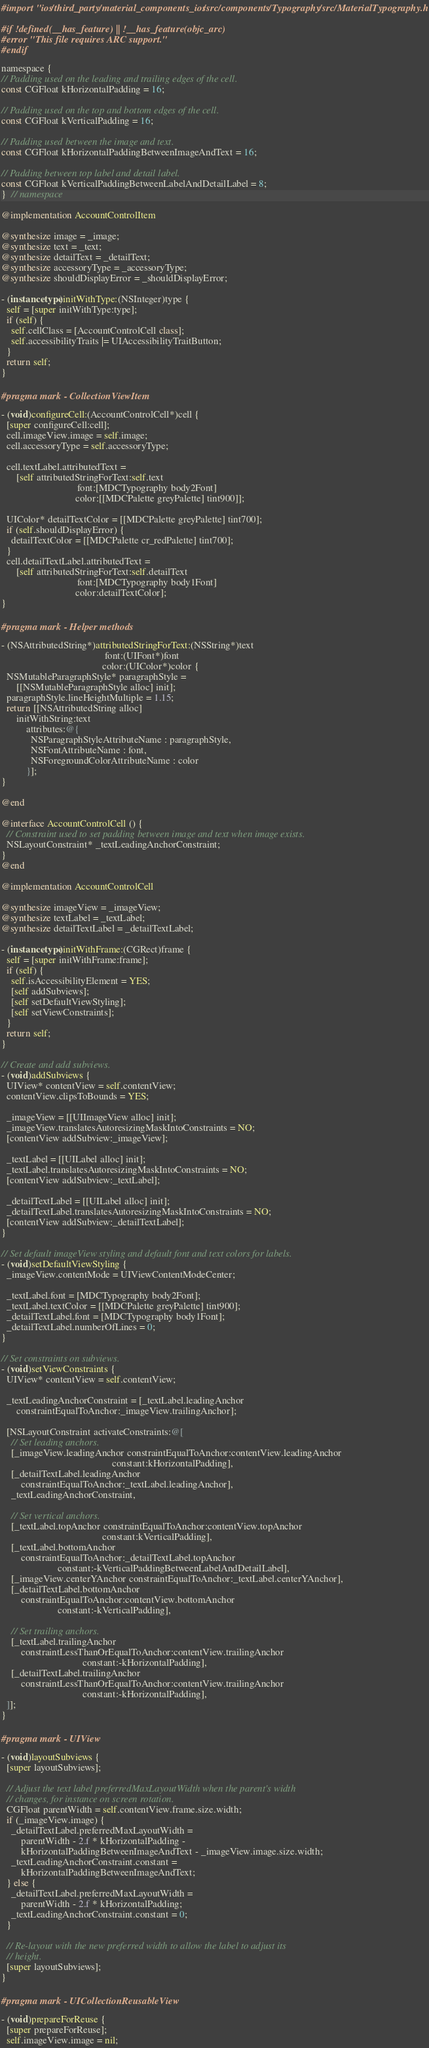<code> <loc_0><loc_0><loc_500><loc_500><_ObjectiveC_>#import "ios/third_party/material_components_ios/src/components/Typography/src/MaterialTypography.h"

#if !defined(__has_feature) || !__has_feature(objc_arc)
#error "This file requires ARC support."
#endif

namespace {
// Padding used on the leading and trailing edges of the cell.
const CGFloat kHorizontalPadding = 16;

// Padding used on the top and bottom edges of the cell.
const CGFloat kVerticalPadding = 16;

// Padding used between the image and text.
const CGFloat kHorizontalPaddingBetweenImageAndText = 16;

// Padding between top label and detail label.
const CGFloat kVerticalPaddingBetweenLabelAndDetailLabel = 8;
}  // namespace

@implementation AccountControlItem

@synthesize image = _image;
@synthesize text = _text;
@synthesize detailText = _detailText;
@synthesize accessoryType = _accessoryType;
@synthesize shouldDisplayError = _shouldDisplayError;

- (instancetype)initWithType:(NSInteger)type {
  self = [super initWithType:type];
  if (self) {
    self.cellClass = [AccountControlCell class];
    self.accessibilityTraits |= UIAccessibilityTraitButton;
  }
  return self;
}

#pragma mark - CollectionViewItem

- (void)configureCell:(AccountControlCell*)cell {
  [super configureCell:cell];
  cell.imageView.image = self.image;
  cell.accessoryType = self.accessoryType;

  cell.textLabel.attributedText =
      [self attributedStringForText:self.text
                               font:[MDCTypography body2Font]
                              color:[[MDCPalette greyPalette] tint900]];

  UIColor* detailTextColor = [[MDCPalette greyPalette] tint700];
  if (self.shouldDisplayError) {
    detailTextColor = [[MDCPalette cr_redPalette] tint700];
  }
  cell.detailTextLabel.attributedText =
      [self attributedStringForText:self.detailText
                               font:[MDCTypography body1Font]
                              color:detailTextColor];
}

#pragma mark - Helper methods

- (NSAttributedString*)attributedStringForText:(NSString*)text
                                          font:(UIFont*)font
                                         color:(UIColor*)color {
  NSMutableParagraphStyle* paragraphStyle =
      [[NSMutableParagraphStyle alloc] init];
  paragraphStyle.lineHeightMultiple = 1.15;
  return [[NSAttributedString alloc]
      initWithString:text
          attributes:@{
            NSParagraphStyleAttributeName : paragraphStyle,
            NSFontAttributeName : font,
            NSForegroundColorAttributeName : color
          }];
}

@end

@interface AccountControlCell () {
  // Constraint used to set padding between image and text when image exists.
  NSLayoutConstraint* _textLeadingAnchorConstraint;
}
@end

@implementation AccountControlCell

@synthesize imageView = _imageView;
@synthesize textLabel = _textLabel;
@synthesize detailTextLabel = _detailTextLabel;

- (instancetype)initWithFrame:(CGRect)frame {
  self = [super initWithFrame:frame];
  if (self) {
    self.isAccessibilityElement = YES;
    [self addSubviews];
    [self setDefaultViewStyling];
    [self setViewConstraints];
  }
  return self;
}

// Create and add subviews.
- (void)addSubviews {
  UIView* contentView = self.contentView;
  contentView.clipsToBounds = YES;

  _imageView = [[UIImageView alloc] init];
  _imageView.translatesAutoresizingMaskIntoConstraints = NO;
  [contentView addSubview:_imageView];

  _textLabel = [[UILabel alloc] init];
  _textLabel.translatesAutoresizingMaskIntoConstraints = NO;
  [contentView addSubview:_textLabel];

  _detailTextLabel = [[UILabel alloc] init];
  _detailTextLabel.translatesAutoresizingMaskIntoConstraints = NO;
  [contentView addSubview:_detailTextLabel];
}

// Set default imageView styling and default font and text colors for labels.
- (void)setDefaultViewStyling {
  _imageView.contentMode = UIViewContentModeCenter;

  _textLabel.font = [MDCTypography body2Font];
  _textLabel.textColor = [[MDCPalette greyPalette] tint900];
  _detailTextLabel.font = [MDCTypography body1Font];
  _detailTextLabel.numberOfLines = 0;
}

// Set constraints on subviews.
- (void)setViewConstraints {
  UIView* contentView = self.contentView;

  _textLeadingAnchorConstraint = [_textLabel.leadingAnchor
      constraintEqualToAnchor:_imageView.trailingAnchor];

  [NSLayoutConstraint activateConstraints:@[
    // Set leading anchors.
    [_imageView.leadingAnchor constraintEqualToAnchor:contentView.leadingAnchor
                                             constant:kHorizontalPadding],
    [_detailTextLabel.leadingAnchor
        constraintEqualToAnchor:_textLabel.leadingAnchor],
    _textLeadingAnchorConstraint,

    // Set vertical anchors.
    [_textLabel.topAnchor constraintEqualToAnchor:contentView.topAnchor
                                         constant:kVerticalPadding],
    [_textLabel.bottomAnchor
        constraintEqualToAnchor:_detailTextLabel.topAnchor
                       constant:-kVerticalPaddingBetweenLabelAndDetailLabel],
    [_imageView.centerYAnchor constraintEqualToAnchor:_textLabel.centerYAnchor],
    [_detailTextLabel.bottomAnchor
        constraintEqualToAnchor:contentView.bottomAnchor
                       constant:-kVerticalPadding],

    // Set trailing anchors.
    [_textLabel.trailingAnchor
        constraintLessThanOrEqualToAnchor:contentView.trailingAnchor
                                 constant:-kHorizontalPadding],
    [_detailTextLabel.trailingAnchor
        constraintLessThanOrEqualToAnchor:contentView.trailingAnchor
                                 constant:-kHorizontalPadding],
  ]];
}

#pragma mark - UIView

- (void)layoutSubviews {
  [super layoutSubviews];

  // Adjust the text label preferredMaxLayoutWidth when the parent's width
  // changes, for instance on screen rotation.
  CGFloat parentWidth = self.contentView.frame.size.width;
  if (_imageView.image) {
    _detailTextLabel.preferredMaxLayoutWidth =
        parentWidth - 2.f * kHorizontalPadding -
        kHorizontalPaddingBetweenImageAndText - _imageView.image.size.width;
    _textLeadingAnchorConstraint.constant =
        kHorizontalPaddingBetweenImageAndText;
  } else {
    _detailTextLabel.preferredMaxLayoutWidth =
        parentWidth - 2.f * kHorizontalPadding;
    _textLeadingAnchorConstraint.constant = 0;
  }

  // Re-layout with the new preferred width to allow the label to adjust its
  // height.
  [super layoutSubviews];
}

#pragma mark - UICollectionReusableView

- (void)prepareForReuse {
  [super prepareForReuse];
  self.imageView.image = nil;</code> 